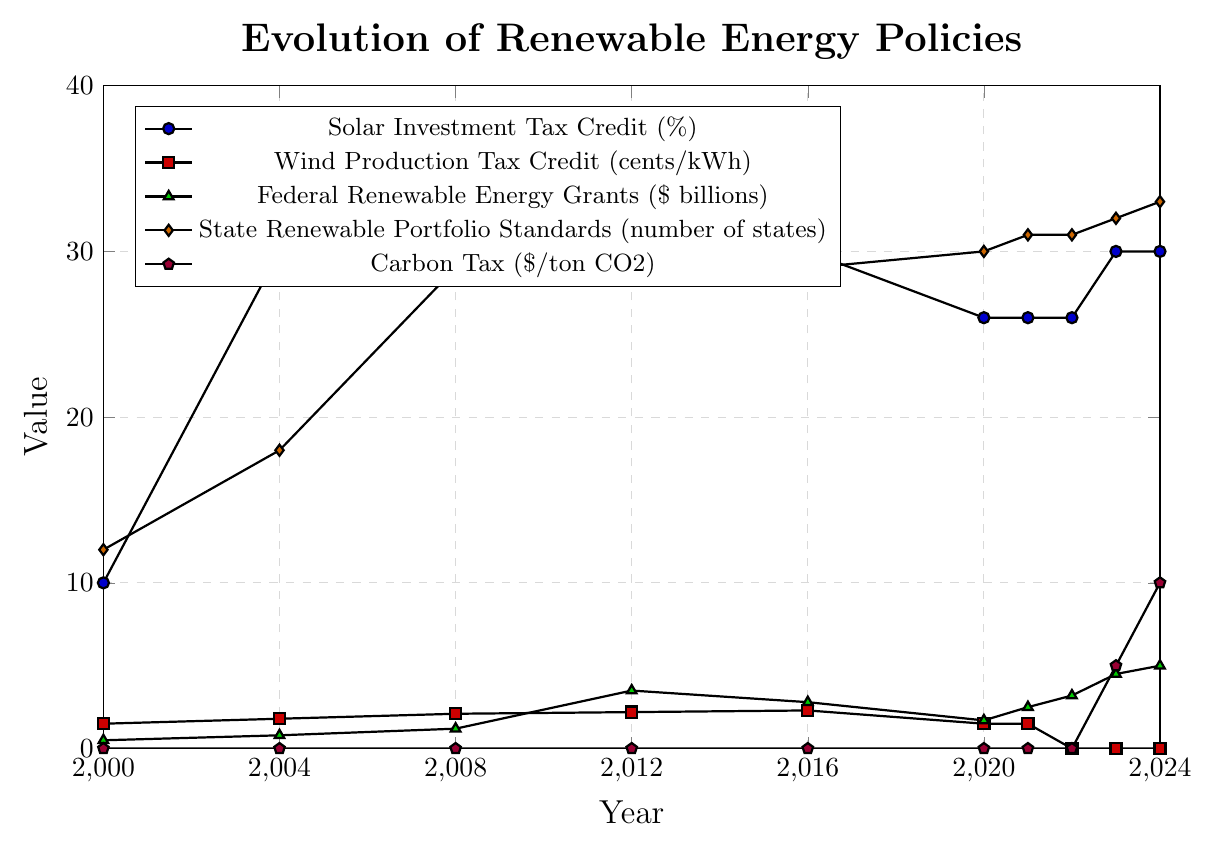What trend do you notice in the Solar Investment Tax Credit from 2000 to 2024? From 2000 to 2004, the Solar Investment Tax Credit increased from 10% to 30%. It remained steady at 30% until 2020, then decreased to 26% from 2020 to 2022, and increased back to 30% in 2023 and 2024.
Answer: The credit generally increased, then decreased, and finally increased again Which year saw the highest value in Federal Renewable Energy Grants, and what was the amount? The highest value for Federal Renewable Energy Grants is in 2024, where it reached $5 billion. This is visible as the peak in the green triangle markers on the graph.
Answer: 2024, $5 billion How did the number of states with Renewable Portfolio Standards change from 2016 to 2024? The number of states with Renewable Portfolio Standards decreased from 37 to 29 from 2012 to 2016 but increased again from 29 in 2016 to 33 in 2024.
Answer: It increased Compare the Wind Production Tax Credit in 2012 and 2024. What difference do you observe? The Wind Production Tax Credit was 2.2 cents/kWh in 2012 and 0 cents/kWh in 2024. The credit decreased by 2.2 cents/kWh from 2012 to 2024, which is indicated by the red squares on the graph.
Answer: It dropped to 0 cents/kWh What is the average value of the Carbon Tax for the years provided in the chart? The values for the Carbon Tax over the years are: 0, 0, 0, 0, 0, 0, 0, 0, 5, and 10. Adding these values gives 15. Dividing by the number of years (10), the average is 15/10 = 1.5.
Answer: 1.5 What are the changes in the Solar Investment Tax Credit from 2020 to 2023? The Solar Investment Tax Credit was 26% in 2020 and remained at 26% in 2021 and 2022. It was increased to 30% in 2023.
Answer: It increased from 26% to 30% How does the trend in Federal Renewable Energy Grants compare to the Solar Investment Tax Credit from 2000 to 2024? The Federal Renewable Energy Grants show a more consistent increase, peaking at $5 billion in 2024, whereas the Solar Investment Tax Credit sees an increase to 30% by 2004, stays level until 2020, drops to 26% until 2023, then goes back to 30% in 2023 and 2024.
Answer: Grants increased consistently, while the credit fluctuated What's the difference in the number of states with Renewable Portfolio Standards between 2000 and 2008? In 2000, 12 states had Renewable Portfolio Standards, and this increased to 29 states by 2008. The difference is 29 - 12 = 17.
Answer: 17 states What significant change occurred in the Carbon Tax between 2022 and 2024? The Carbon Tax increased from $0/ton CO2 in 2022 to $5/ton in 2023 and then to $10/ton in 2024.
Answer: Introduced and increased to $10/ton CO2 